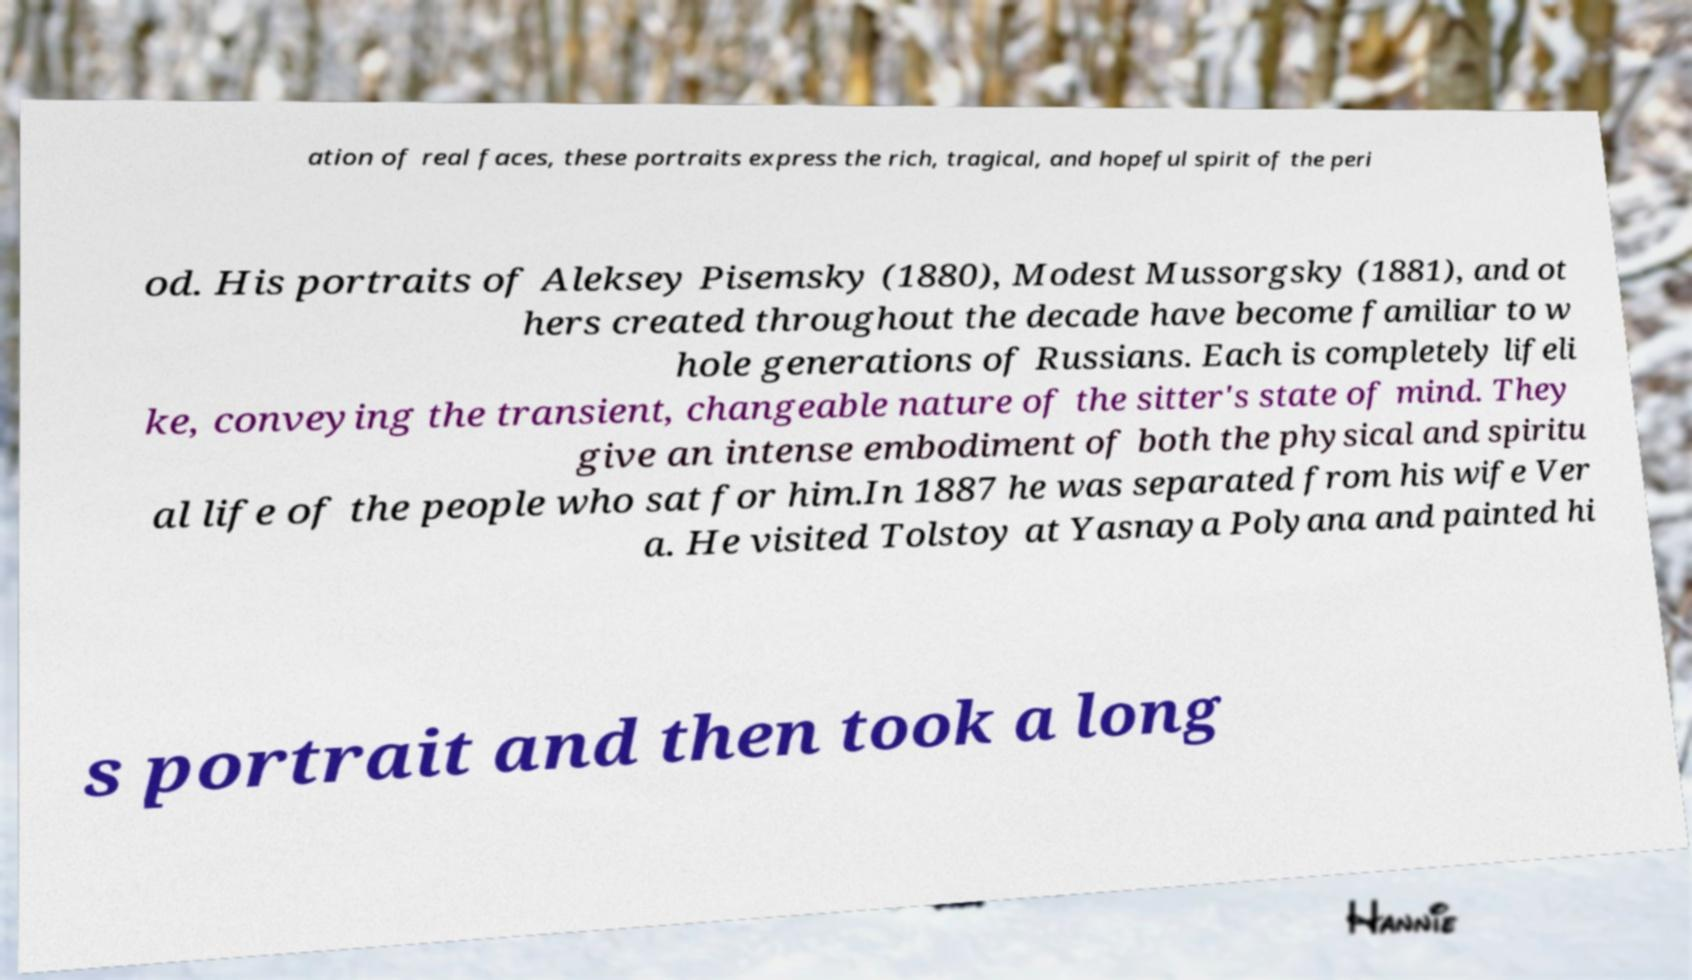Could you assist in decoding the text presented in this image and type it out clearly? ation of real faces, these portraits express the rich, tragical, and hopeful spirit of the peri od. His portraits of Aleksey Pisemsky (1880), Modest Mussorgsky (1881), and ot hers created throughout the decade have become familiar to w hole generations of Russians. Each is completely lifeli ke, conveying the transient, changeable nature of the sitter's state of mind. They give an intense embodiment of both the physical and spiritu al life of the people who sat for him.In 1887 he was separated from his wife Ver a. He visited Tolstoy at Yasnaya Polyana and painted hi s portrait and then took a long 